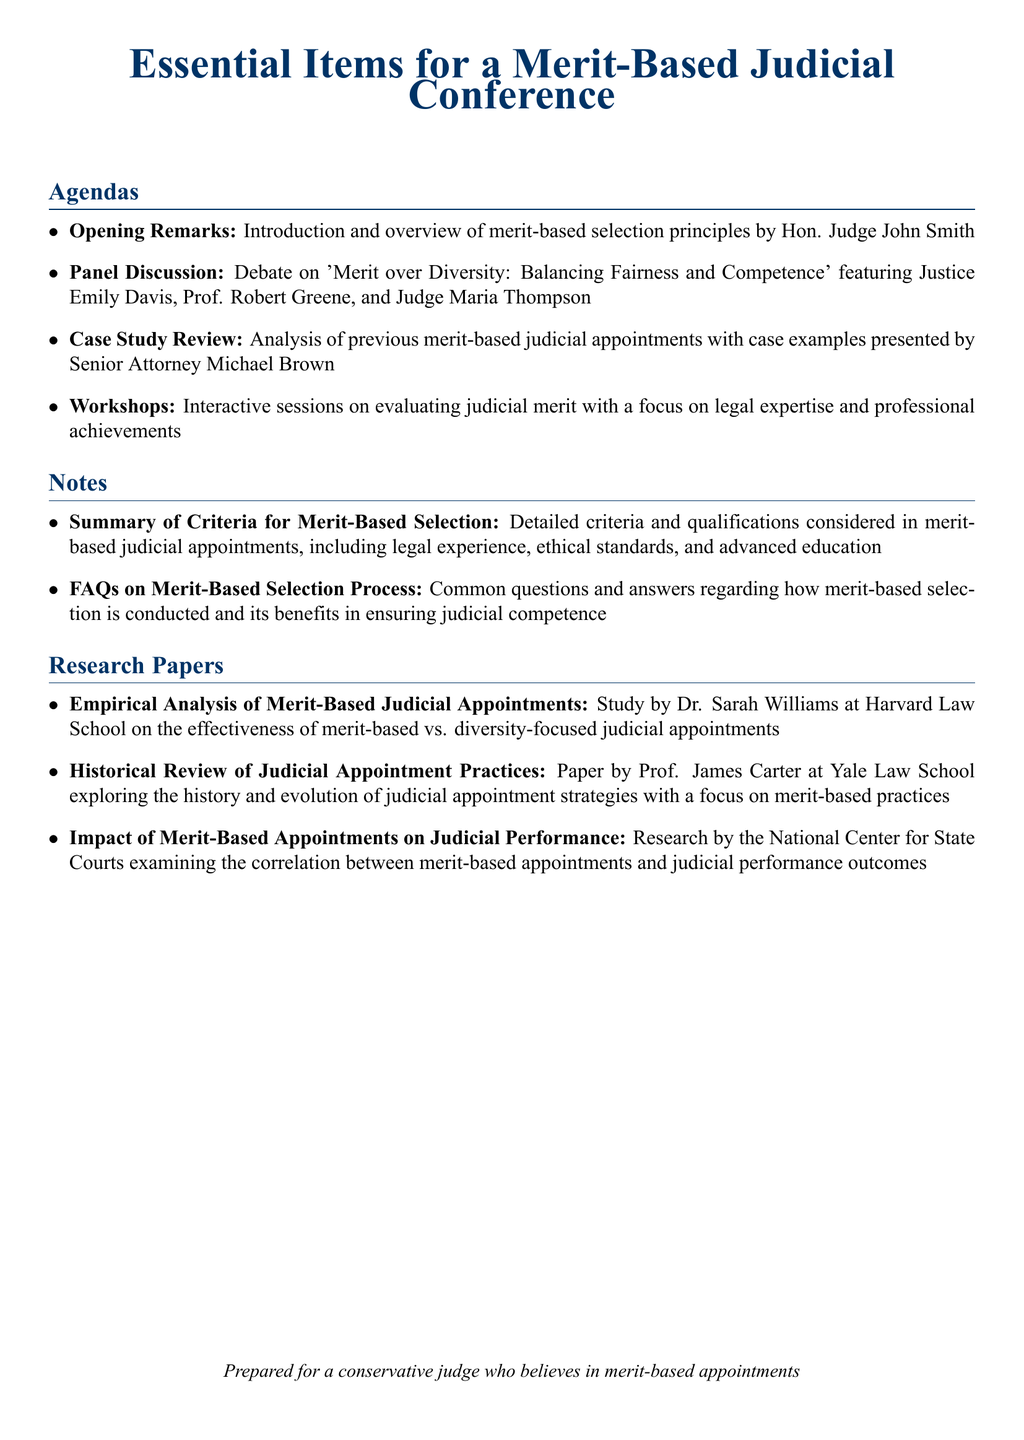What is the opening remarks topic? The opening remarks topic is "Introduction and overview of merit-based selection principles."
Answer: Introduction and overview of merit-based selection principles Who is presenting the panel discussion? The panel discussion features Justice Emily Davis, Prof. Robert Greene, and Judge Maria Thompson.
Answer: Justice Emily Davis, Prof. Robert Greene, and Judge Maria Thompson What is the focus of the workshops? The focus of the workshops is on evaluating judicial merit with a focus on legal expertise and professional achievements.
Answer: Evaluating judicial merit with a focus on legal expertise and professional achievements Which institution published the paper on empirical analysis? The paper on empirical analysis was published by Harvard Law School.
Answer: Harvard Law School What common theme is discussed in the notes section? The common theme discussed in the notes section is merit-based selection criteria.
Answer: Merit-based selection criteria How many research papers are listed? There are three research papers listed in the document.
Answer: Three What type of conference is this document prepared for? The document is prepared for a merit-based judicial conference.
Answer: Merit-based judicial conference Who authored the research on the impact of merit-based appointments? The research on the impact of merit-based appointments is authored by the National Center for State Courts.
Answer: National Center for State Courts What is the tone of the document aimed at? The tone of the document is aimed at a conservative judge who believes in merit-based appointments.
Answer: Conservative judge who believes in merit-based appointments 